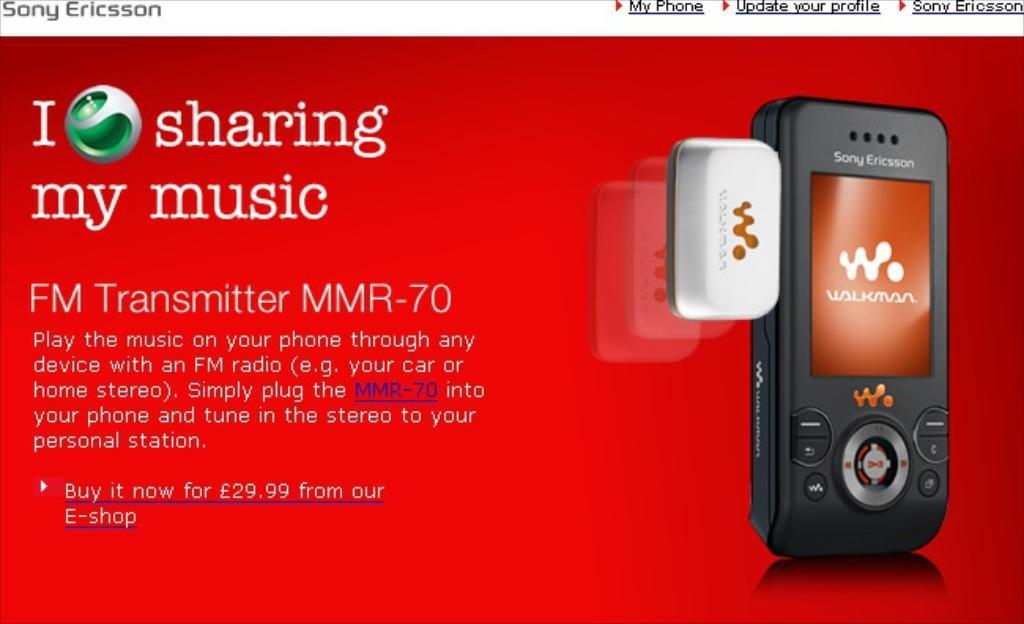<image>
Relay a brief, clear account of the picture shown. an advertisement for sharing music from sony ericsson 